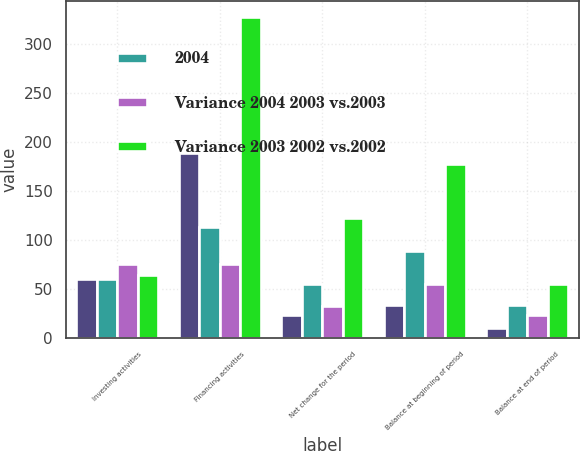Convert chart to OTSL. <chart><loc_0><loc_0><loc_500><loc_500><stacked_bar_chart><ecel><fcel>Investing activities<fcel>Financing activities<fcel>Net change for the period<fcel>Balance at beginning of period<fcel>Balance at end of period<nl><fcel>nan<fcel>59.5<fcel>188<fcel>23<fcel>33<fcel>10<nl><fcel>2004<fcel>59.5<fcel>113<fcel>55<fcel>88<fcel>33<nl><fcel>Variance 2004 2003 vs.2003<fcel>75<fcel>75<fcel>32<fcel>55<fcel>23<nl><fcel>Variance 2003 2002 vs.2002<fcel>64<fcel>327<fcel>122<fcel>177<fcel>55<nl></chart> 